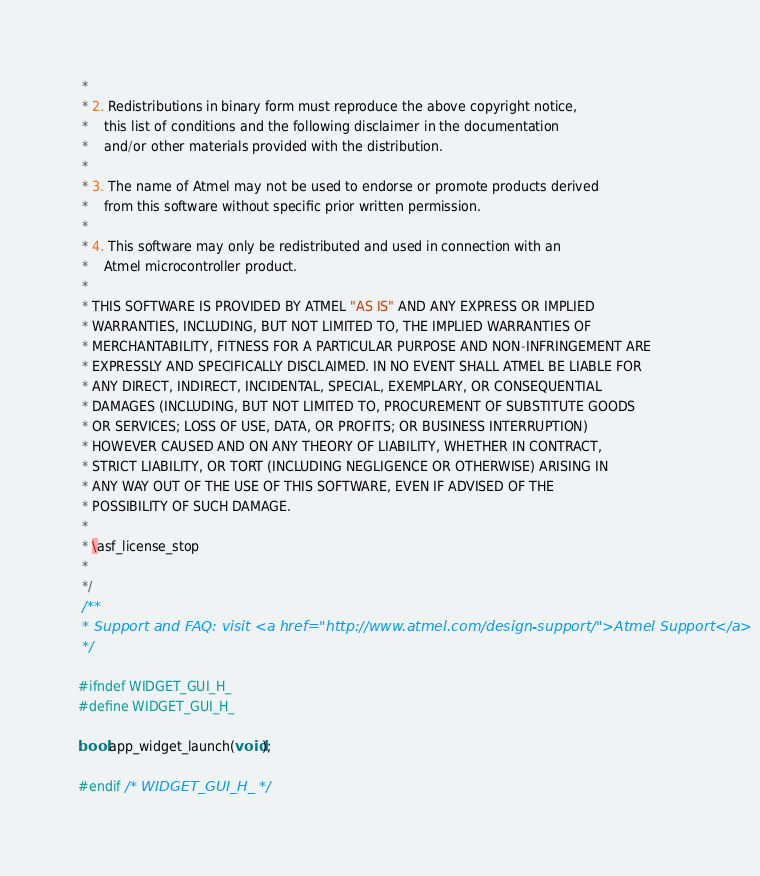Convert code to text. <code><loc_0><loc_0><loc_500><loc_500><_C_> *
 * 2. Redistributions in binary form must reproduce the above copyright notice,
 *    this list of conditions and the following disclaimer in the documentation
 *    and/or other materials provided with the distribution.
 *
 * 3. The name of Atmel may not be used to endorse or promote products derived
 *    from this software without specific prior written permission.
 *
 * 4. This software may only be redistributed and used in connection with an
 *    Atmel microcontroller product.
 *
 * THIS SOFTWARE IS PROVIDED BY ATMEL "AS IS" AND ANY EXPRESS OR IMPLIED
 * WARRANTIES, INCLUDING, BUT NOT LIMITED TO, THE IMPLIED WARRANTIES OF
 * MERCHANTABILITY, FITNESS FOR A PARTICULAR PURPOSE AND NON-INFRINGEMENT ARE
 * EXPRESSLY AND SPECIFICALLY DISCLAIMED. IN NO EVENT SHALL ATMEL BE LIABLE FOR
 * ANY DIRECT, INDIRECT, INCIDENTAL, SPECIAL, EXEMPLARY, OR CONSEQUENTIAL
 * DAMAGES (INCLUDING, BUT NOT LIMITED TO, PROCUREMENT OF SUBSTITUTE GOODS
 * OR SERVICES; LOSS OF USE, DATA, OR PROFITS; OR BUSINESS INTERRUPTION)
 * HOWEVER CAUSED AND ON ANY THEORY OF LIABILITY, WHETHER IN CONTRACT,
 * STRICT LIABILITY, OR TORT (INCLUDING NEGLIGENCE OR OTHERWISE) ARISING IN
 * ANY WAY OUT OF THE USE OF THIS SOFTWARE, EVEN IF ADVISED OF THE
 * POSSIBILITY OF SUCH DAMAGE.
 *
 * \asf_license_stop
 *
 */
 /**
 * Support and FAQ: visit <a href="http://www.atmel.com/design-support/">Atmel Support</a>
 */

#ifndef WIDGET_GUI_H_
#define WIDGET_GUI_H_

bool app_widget_launch(void);

#endif /* WIDGET_GUI_H_ */
</code> 